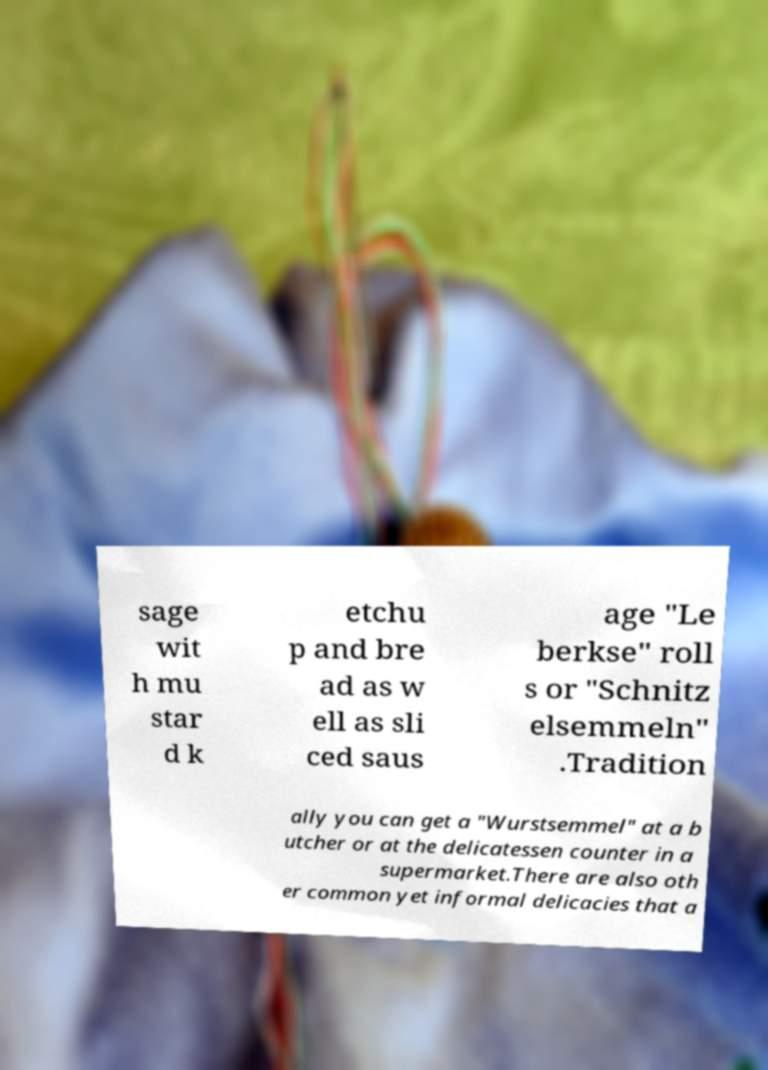There's text embedded in this image that I need extracted. Can you transcribe it verbatim? sage wit h mu star d k etchu p and bre ad as w ell as sli ced saus age "Le berkse" roll s or "Schnitz elsemmeln" .Tradition ally you can get a "Wurstsemmel" at a b utcher or at the delicatessen counter in a supermarket.There are also oth er common yet informal delicacies that a 